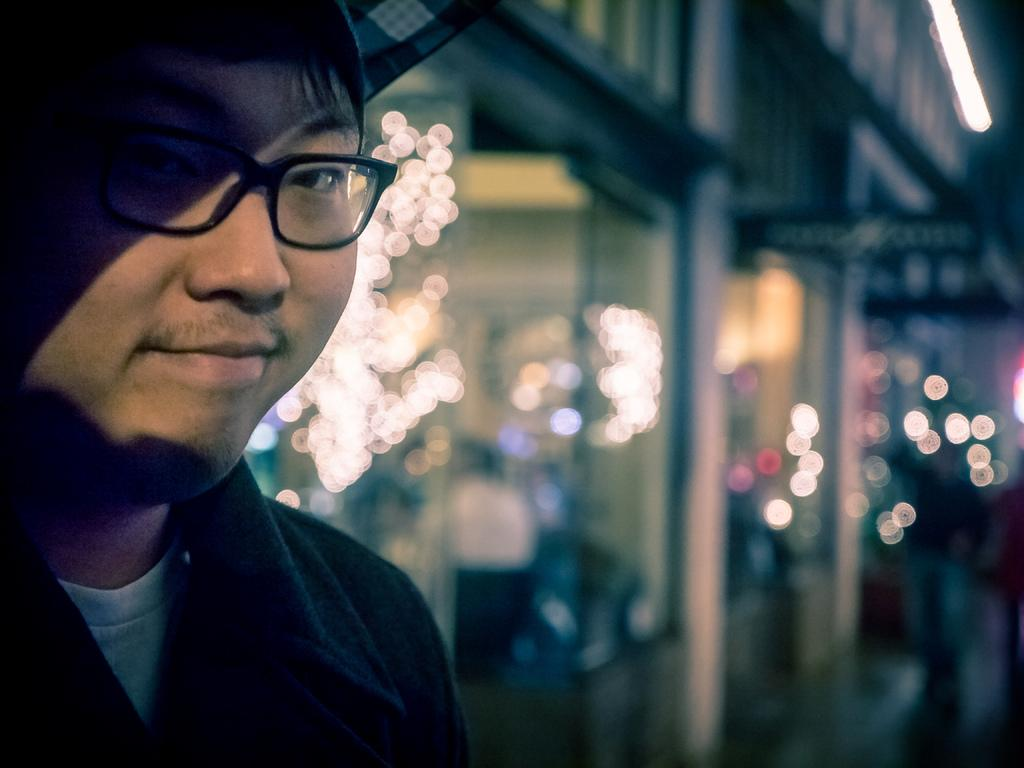What can be seen in the image? There is a person in the image. Can you describe the person's appearance? The person is wearing spectacles. What is the background of the image like? The background of the image is blurry. What type of whip is being used in the image? There is no whip present in the image. 